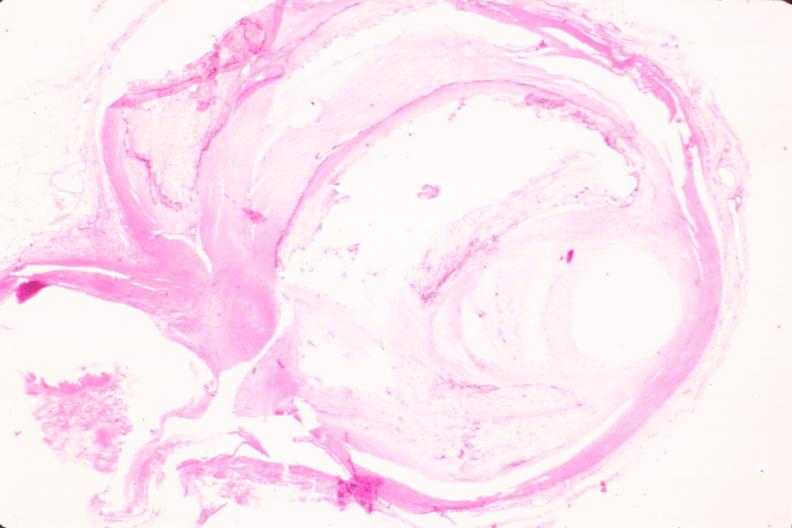what does this image show?
Answer the question using a single word or phrase. Coronary artery atherosclerosis 